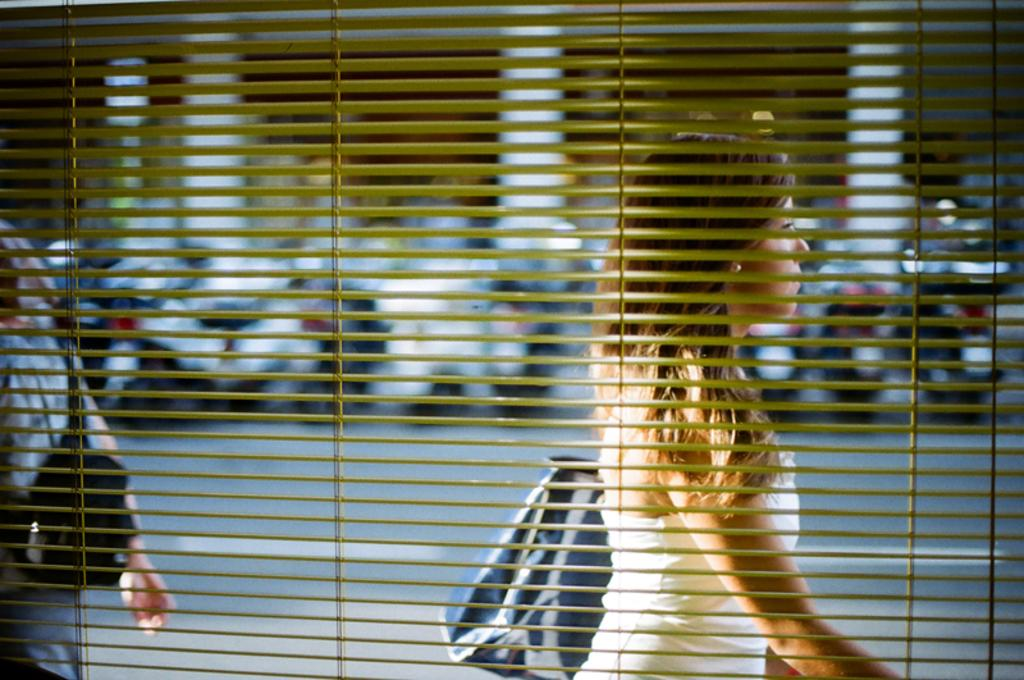What are the people in the image doing? The people in the image are walking. What are the people wearing that are visible in the image? The people are wearing bags. What can be seen in the background of the image? There are motorcycles in the background of the image. What type of crow can be seen interacting with the acoustics of the motorcycles in the image? There is no crow present in the image, and the motorcycles are in the background, so it is not possible to determine any interaction with acoustics. 